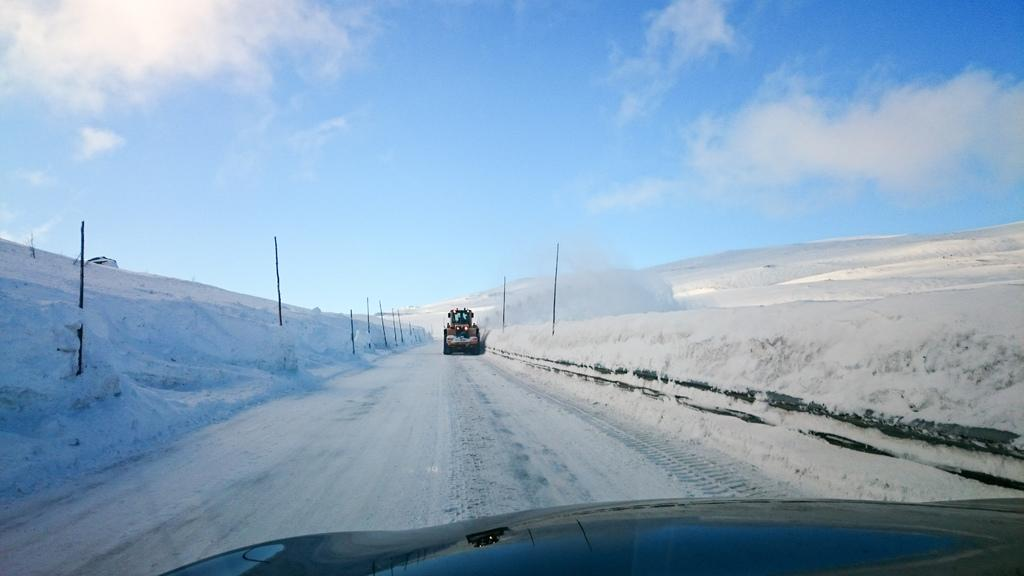How many vehicles can be seen on the road in the image? There are two vehicles on the road in the image. What is the condition of the road in the image? The road has snow on both sides. What can be seen on both sides of the road? There are poles on both sides of the road. What is visible at the top of the image? The sky is visible at the top of the image. What can be observed in the sky? Clouds are present in the sky. Can you tell me how many drawers are in the cat's house in the image? There is no cat or house present in the image, so it is not possible to determine the number of drawers in a cat's house. 